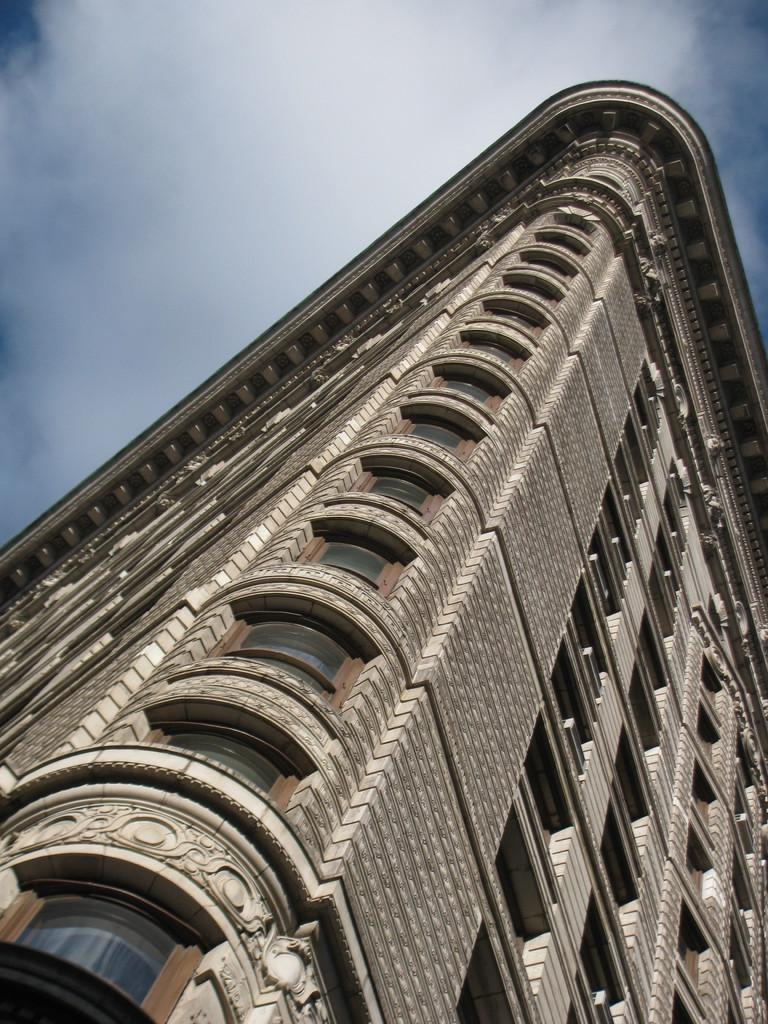What is the main structure in the image? There is a building in the image. What feature can be seen on the building? The building has windows. What can be seen in the background of the image? The sky is visible in the background of the image. What type of basin can be seen in the image? There is no basin present in the image. 